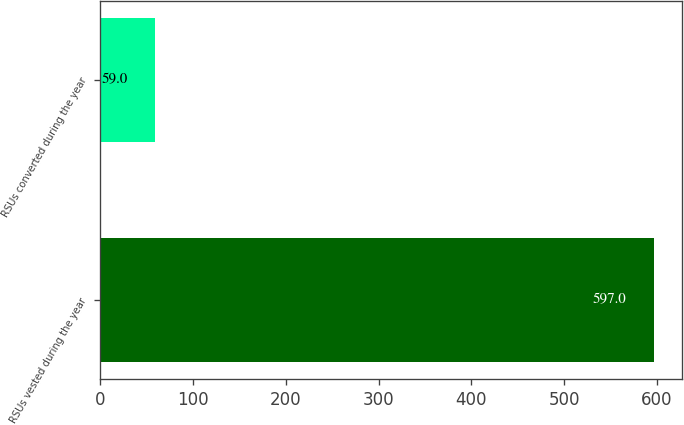Convert chart. <chart><loc_0><loc_0><loc_500><loc_500><bar_chart><fcel>RSUs vested during the year<fcel>RSUs converted during the year<nl><fcel>597<fcel>59<nl></chart> 